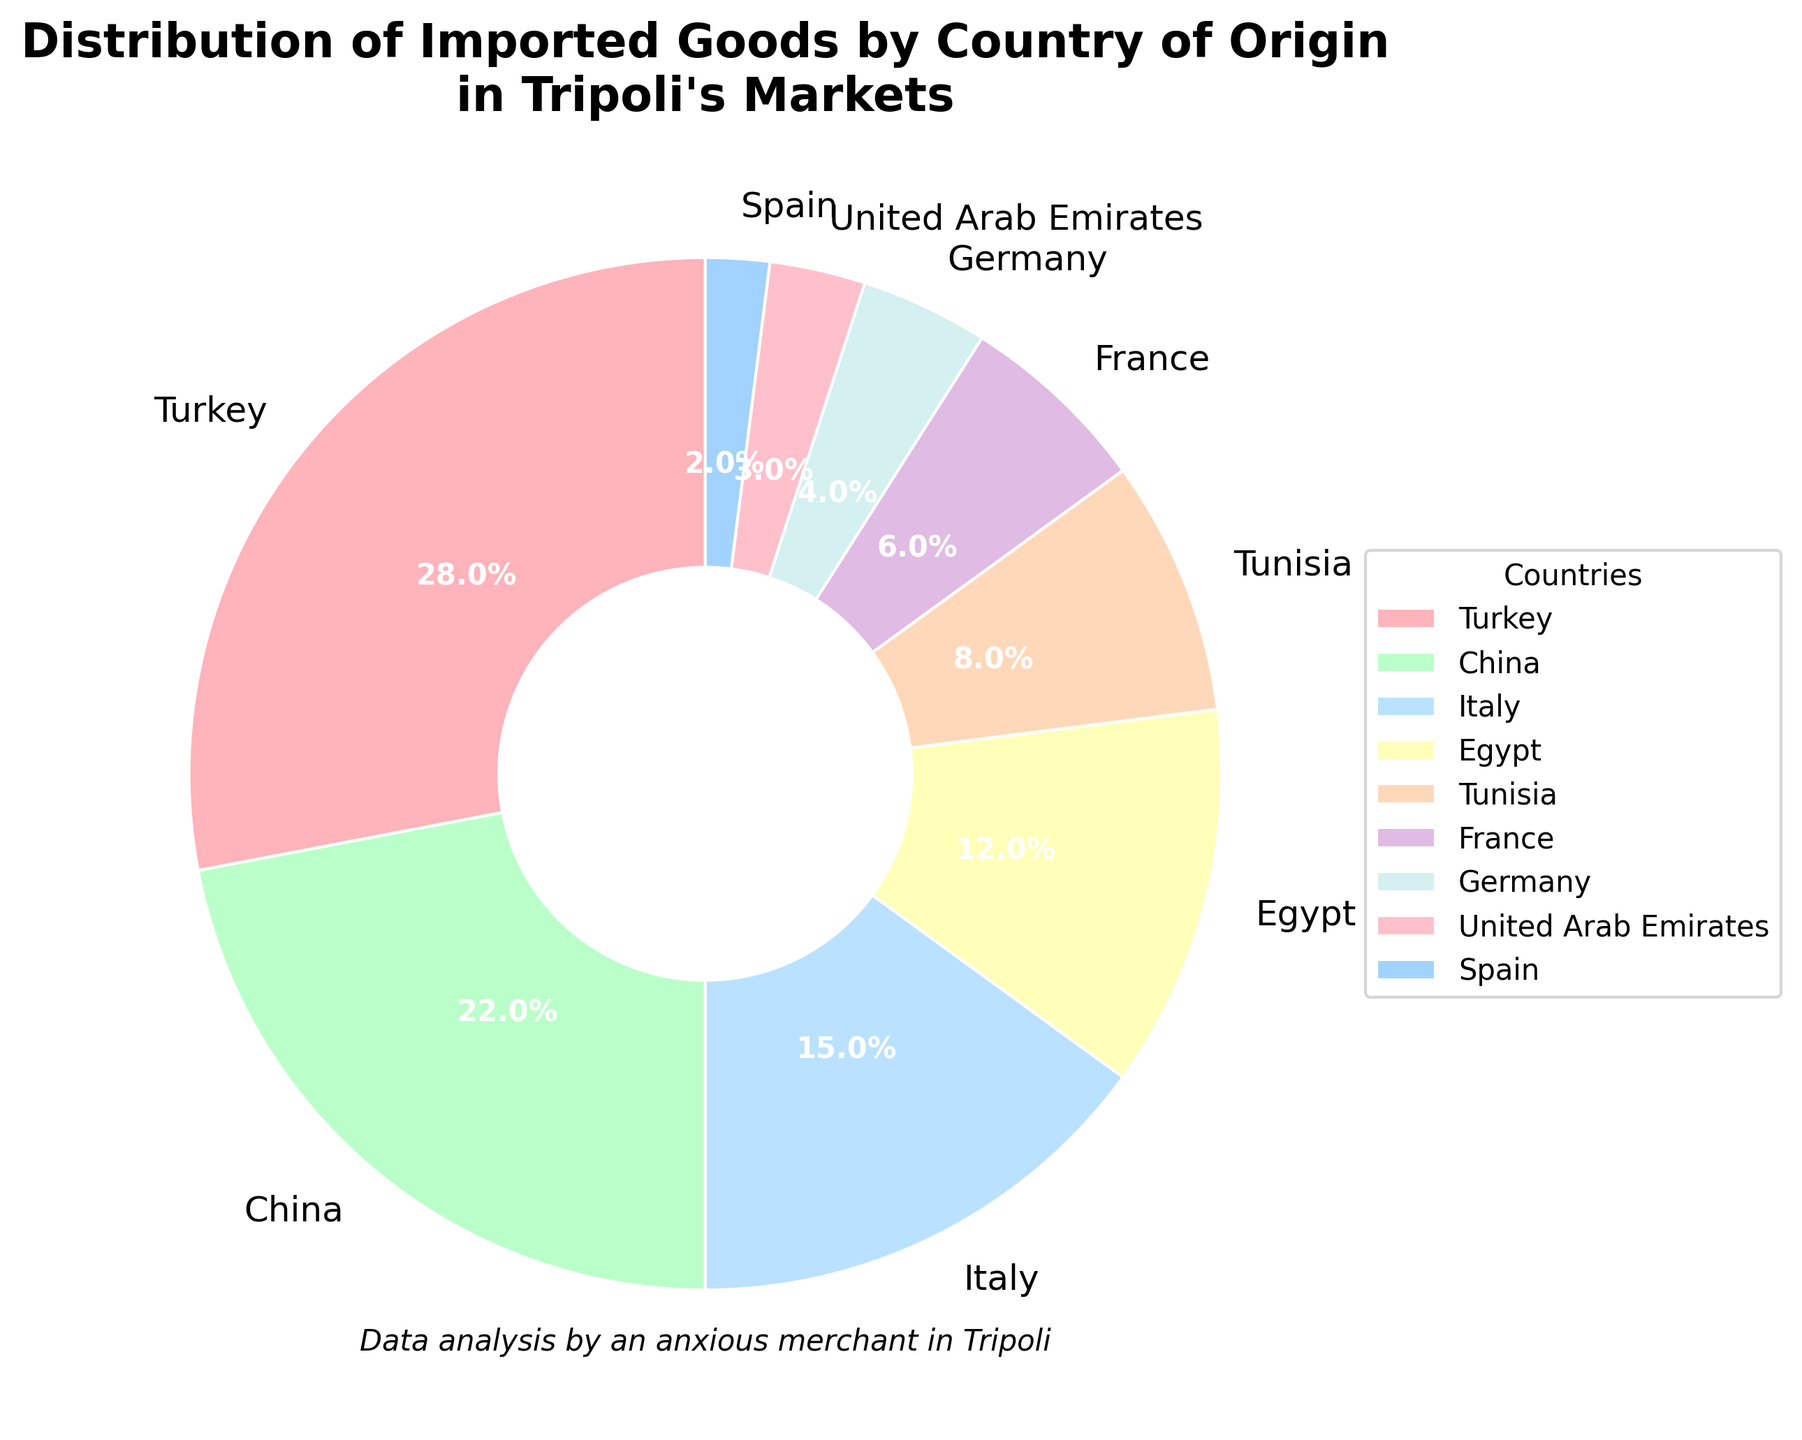What's the sum of percentages for Turkey and China? The percentage for Turkey is 28% and for China is 22%. Summing these gives 28 + 22 = 50.
Answer: 50% Which country has the smallest representation in the imported goods? By looking at the pie chart, we see that Spain has the smallest slice, representing 2%.
Answer: Spain What is the percentage difference between Italy and France? Italy has a percentage of 15%, and France has 6%. Subtracting these gives 15 - 6 = 9.
Answer: 9% How many countries have a contribution of 10% or higher? We can see that Turkey (28%), China (22%), Italy (15%), and Egypt (12%) all have contributions of 10% or higher. Counting these gives us 4 countries.
Answer: 4 Which country has a higher contribution, Tunisia or Germany, and by how much? Tunisia's contribution is 8%, and Germany's is 4%. The difference is 8 - 4 = 4. Tunisia has a higher contribution by 4%.
Answer: Tunisia by 4% What is the combined contribution of France, Germany, and the United Arab Emirates? France contributes 6%, Germany 4%, and the United Arab Emirates 3%. Summing these gives 6 + 4 + 3 = 13.
Answer: 13% Which countries have contributions less than 10%? Countries with contributions less than 10% are Tunisia (8%), France (6%), Germany (4%), United Arab Emirates (3%), and Spain (2%).
Answer: Tunisia, France, Germany, UAE, Spain Do Italy and Tunisia together account for more than 20% of the imported goods? Italy accounts for 15% and Tunisia for 8%. Together, their contributions sum to 15 + 8 = 23, which is more than 20%.
Answer: Yes Which segment of the pie is represented with a purple color? The purple section in the pie chart corresponds to Italy.
Answer: Italy 